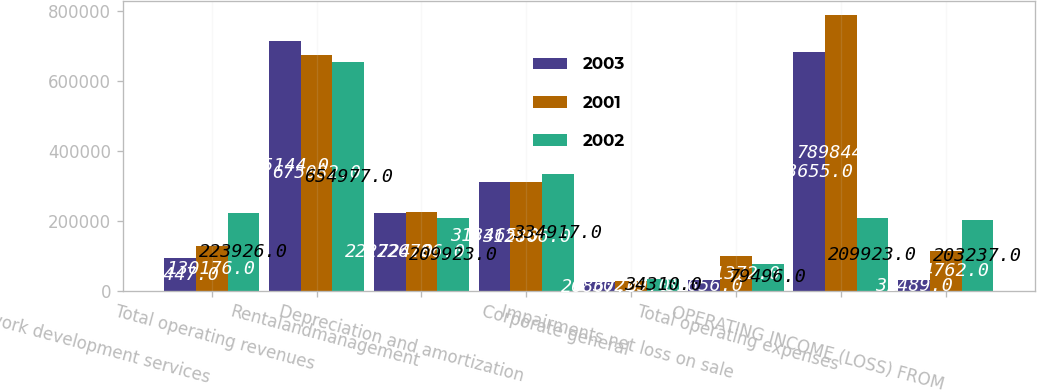<chart> <loc_0><loc_0><loc_500><loc_500><stacked_bar_chart><ecel><fcel>Network development services<fcel>Total operating revenues<fcel>Rentalandmanagement<fcel>Depreciation and amortization<fcel>Corporate general<fcel>Impairments net loss on sale<fcel>Total operating expenses<fcel>OPERATING INCOME (LOSS) FROM<nl><fcel>2003<fcel>95447<fcel>715144<fcel>222724<fcel>313465<fcel>26867<fcel>31656<fcel>683655<fcel>31489<nl><fcel>2001<fcel>130176<fcel>675082<fcel>226786<fcel>312866<fcel>30229<fcel>101372<fcel>789844<fcel>114762<nl><fcel>2002<fcel>223926<fcel>654977<fcel>209923<fcel>334917<fcel>34310<fcel>79496<fcel>209923<fcel>203237<nl></chart> 